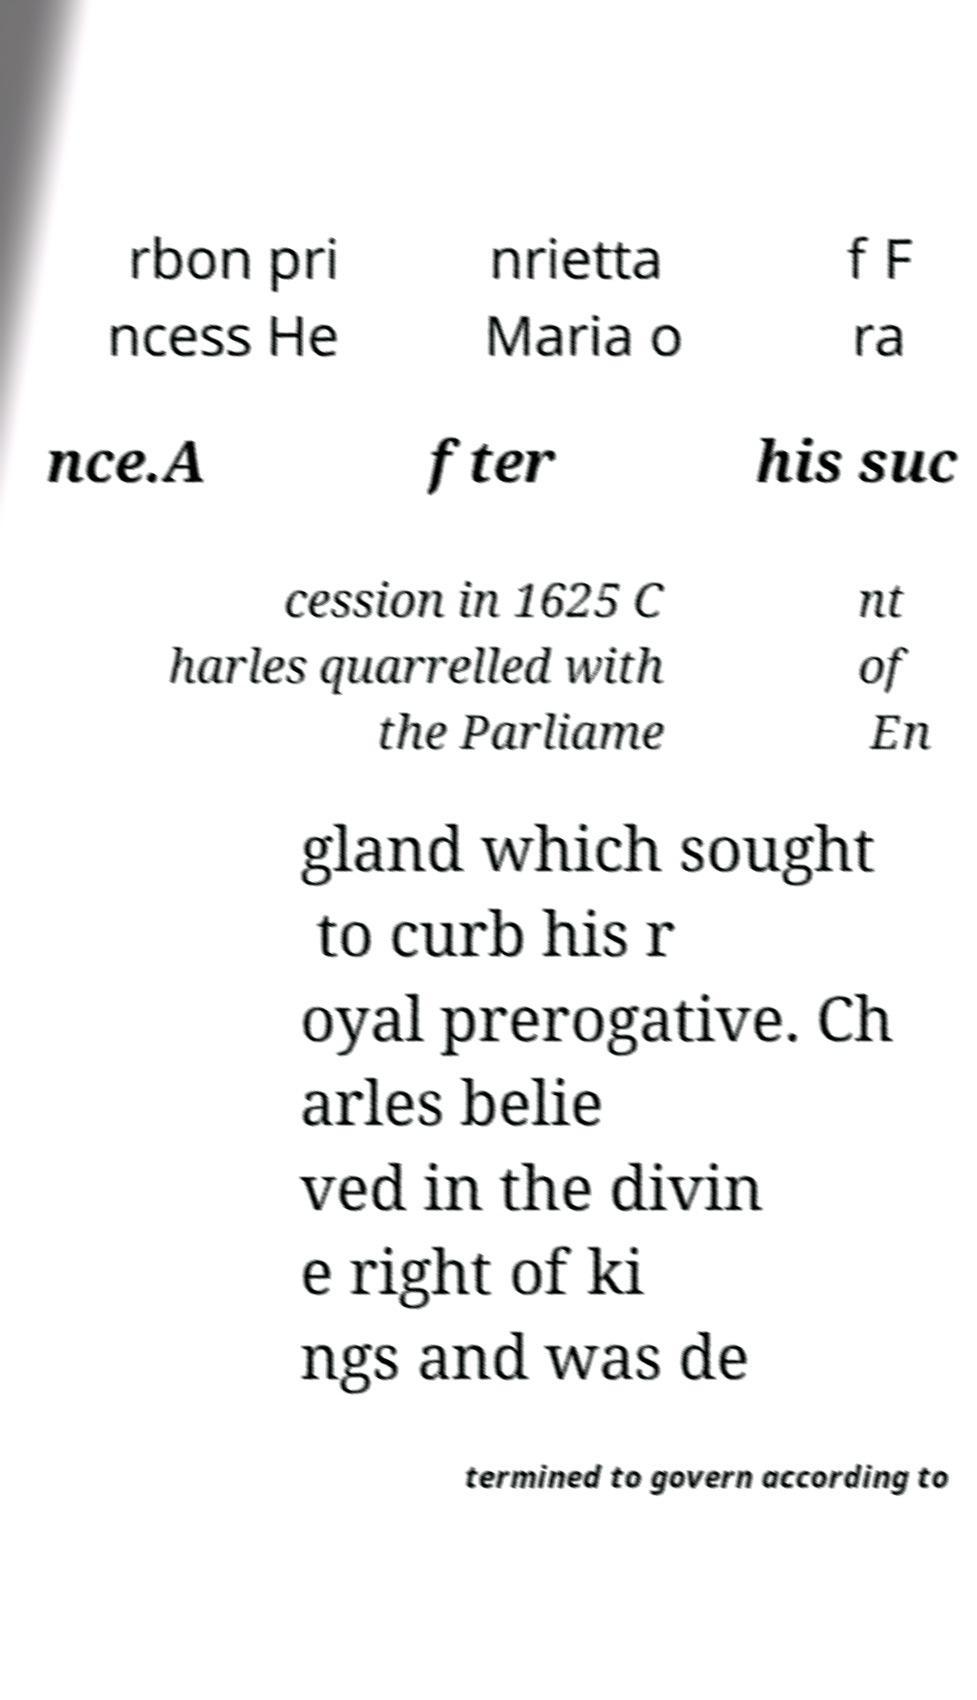Can you accurately transcribe the text from the provided image for me? rbon pri ncess He nrietta Maria o f F ra nce.A fter his suc cession in 1625 C harles quarrelled with the Parliame nt of En gland which sought to curb his r oyal prerogative. Ch arles belie ved in the divin e right of ki ngs and was de termined to govern according to 